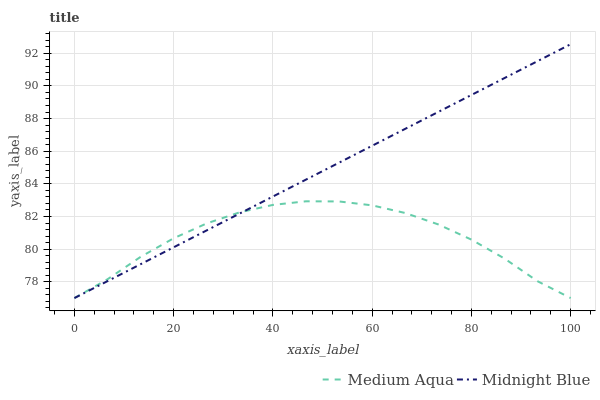Does Medium Aqua have the minimum area under the curve?
Answer yes or no. Yes. Does Midnight Blue have the maximum area under the curve?
Answer yes or no. Yes. Does Midnight Blue have the minimum area under the curve?
Answer yes or no. No. Is Midnight Blue the smoothest?
Answer yes or no. Yes. Is Medium Aqua the roughest?
Answer yes or no. Yes. Is Midnight Blue the roughest?
Answer yes or no. No. Does Medium Aqua have the lowest value?
Answer yes or no. Yes. Does Midnight Blue have the highest value?
Answer yes or no. Yes. Does Midnight Blue intersect Medium Aqua?
Answer yes or no. Yes. Is Midnight Blue less than Medium Aqua?
Answer yes or no. No. Is Midnight Blue greater than Medium Aqua?
Answer yes or no. No. 